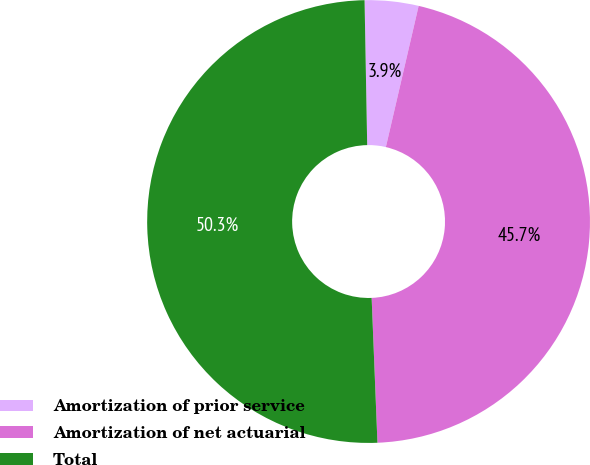Convert chart to OTSL. <chart><loc_0><loc_0><loc_500><loc_500><pie_chart><fcel>Amortization of prior service<fcel>Amortization of net actuarial<fcel>Total<nl><fcel>3.92%<fcel>45.73%<fcel>50.35%<nl></chart> 